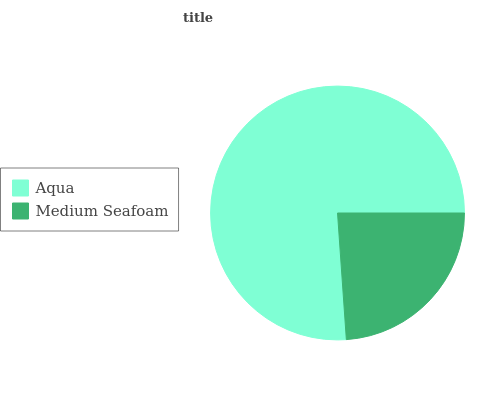Is Medium Seafoam the minimum?
Answer yes or no. Yes. Is Aqua the maximum?
Answer yes or no. Yes. Is Medium Seafoam the maximum?
Answer yes or no. No. Is Aqua greater than Medium Seafoam?
Answer yes or no. Yes. Is Medium Seafoam less than Aqua?
Answer yes or no. Yes. Is Medium Seafoam greater than Aqua?
Answer yes or no. No. Is Aqua less than Medium Seafoam?
Answer yes or no. No. Is Aqua the high median?
Answer yes or no. Yes. Is Medium Seafoam the low median?
Answer yes or no. Yes. Is Medium Seafoam the high median?
Answer yes or no. No. Is Aqua the low median?
Answer yes or no. No. 